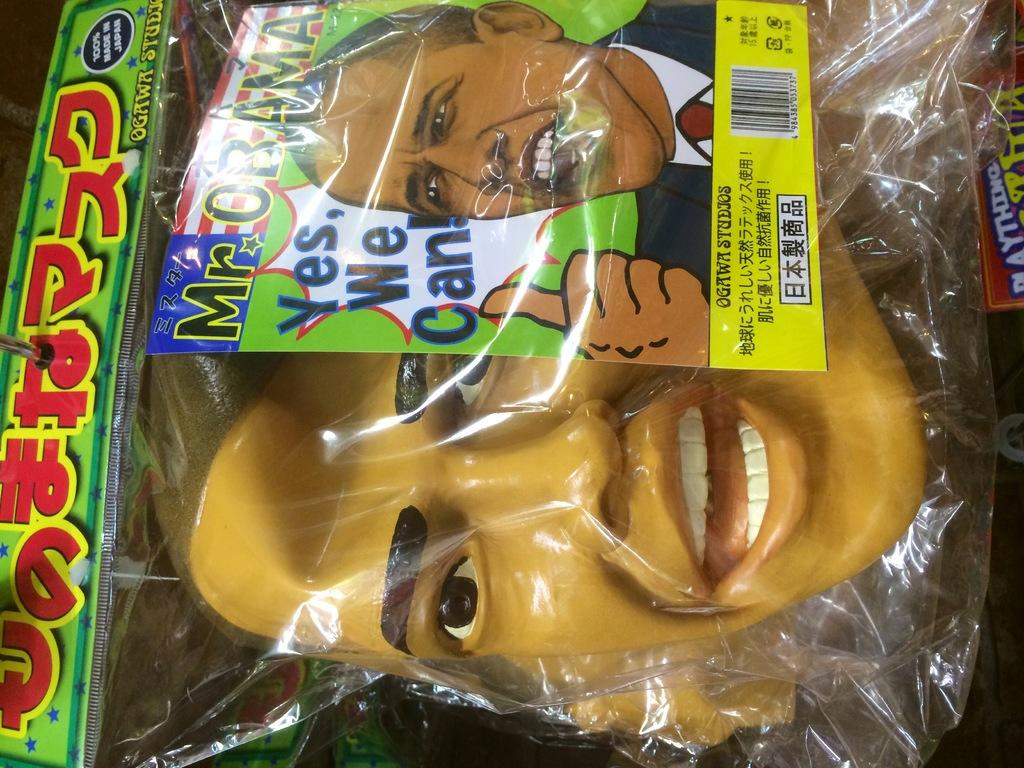What is the main object in the image? There is a face mask in the image. How is the face mask being stored or protected? The face mask is inside a cover. Can you see a giraffe in the image? No, there is no giraffe present in the image. What type of reward is being given for wearing the face mask in the image? There is no reward mentioned or depicted in the image. 